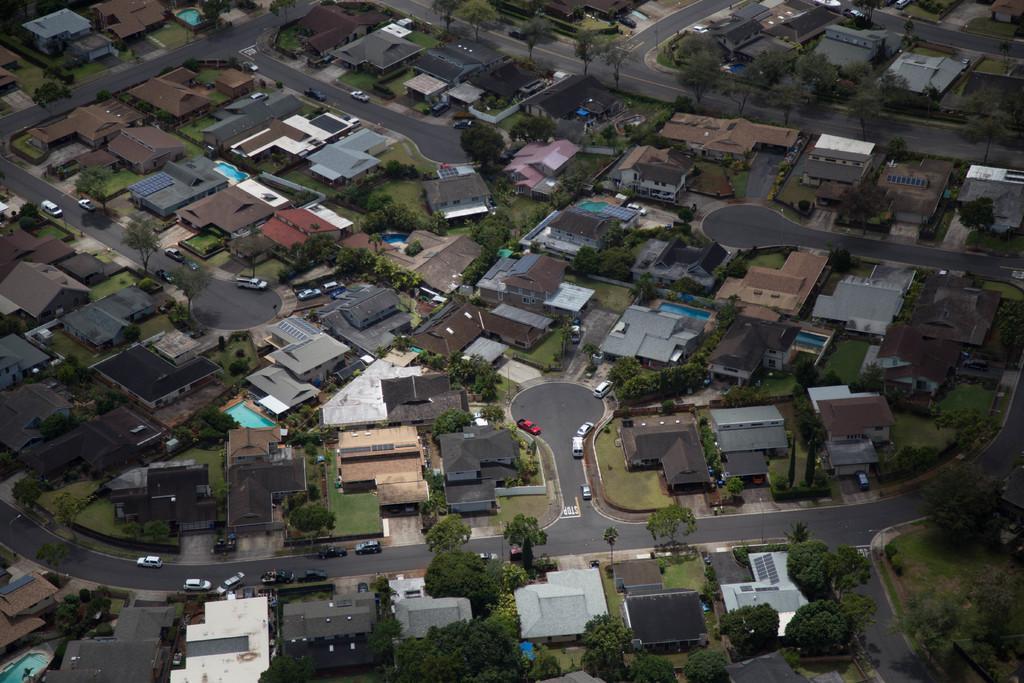In one or two sentences, can you explain what this image depicts? In this image we can see many buildings. Also there are trees, roads and vehicles. 